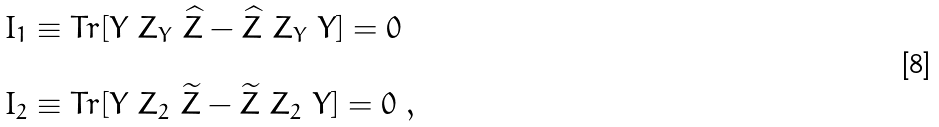<formula> <loc_0><loc_0><loc_500><loc_500>\begin{array} { l } I _ { 1 } \equiv T r [ Y \ Z _ { Y } \ \widehat { Z } - \widehat { Z } \ Z _ { Y } \ Y ] = 0 \\ \\ I _ { 2 } \equiv T r [ Y \ Z _ { 2 } \ \widetilde { Z } - \widetilde { Z } \ Z _ { 2 } \ Y ] = 0 \ , \end{array}</formula> 